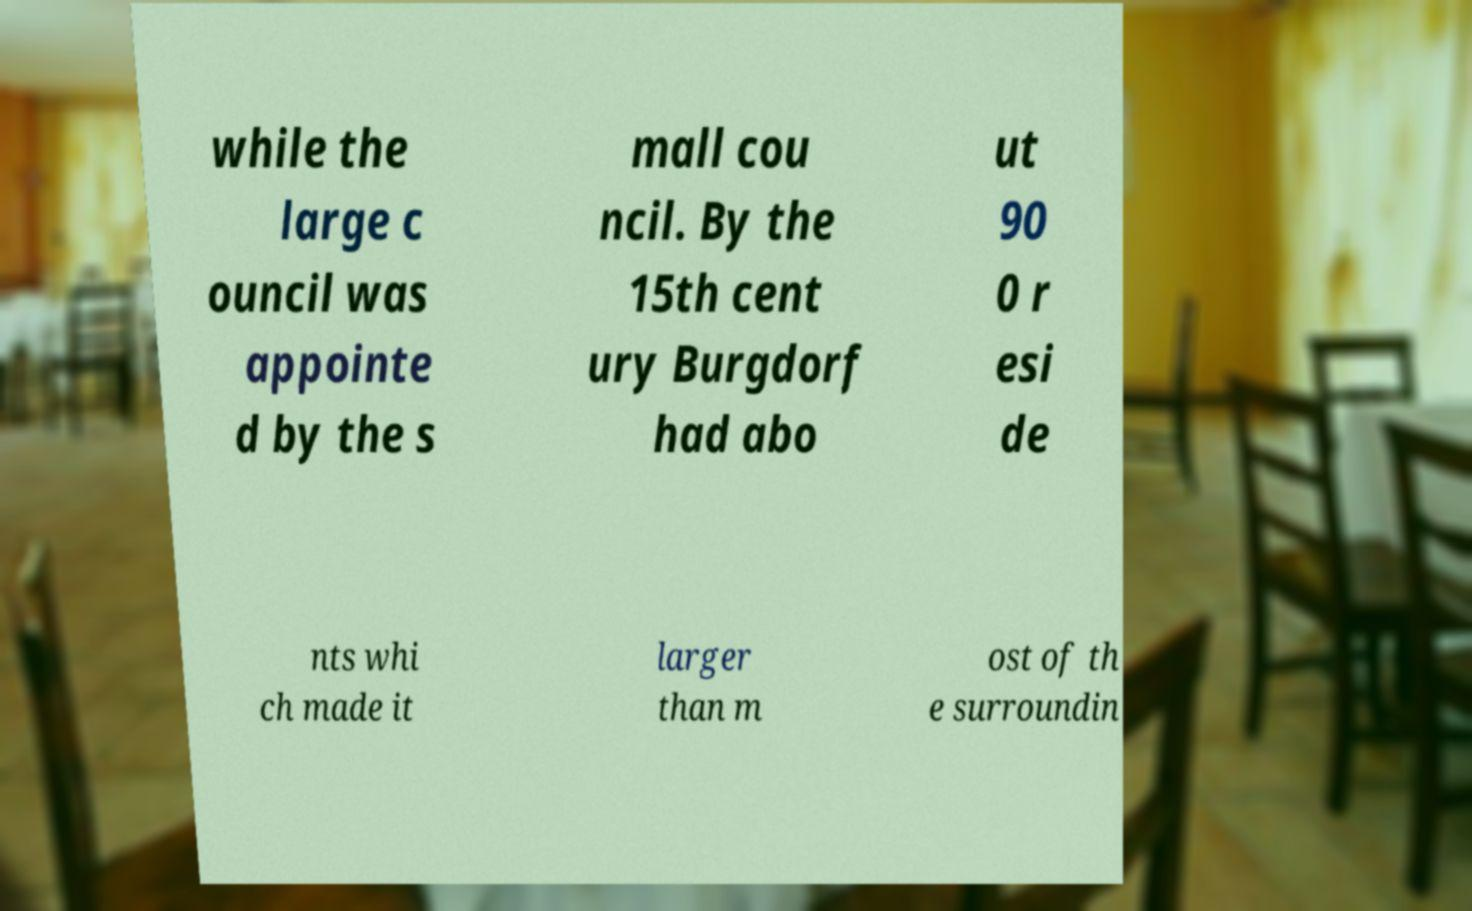Please read and relay the text visible in this image. What does it say? while the large c ouncil was appointe d by the s mall cou ncil. By the 15th cent ury Burgdorf had abo ut 90 0 r esi de nts whi ch made it larger than m ost of th e surroundin 